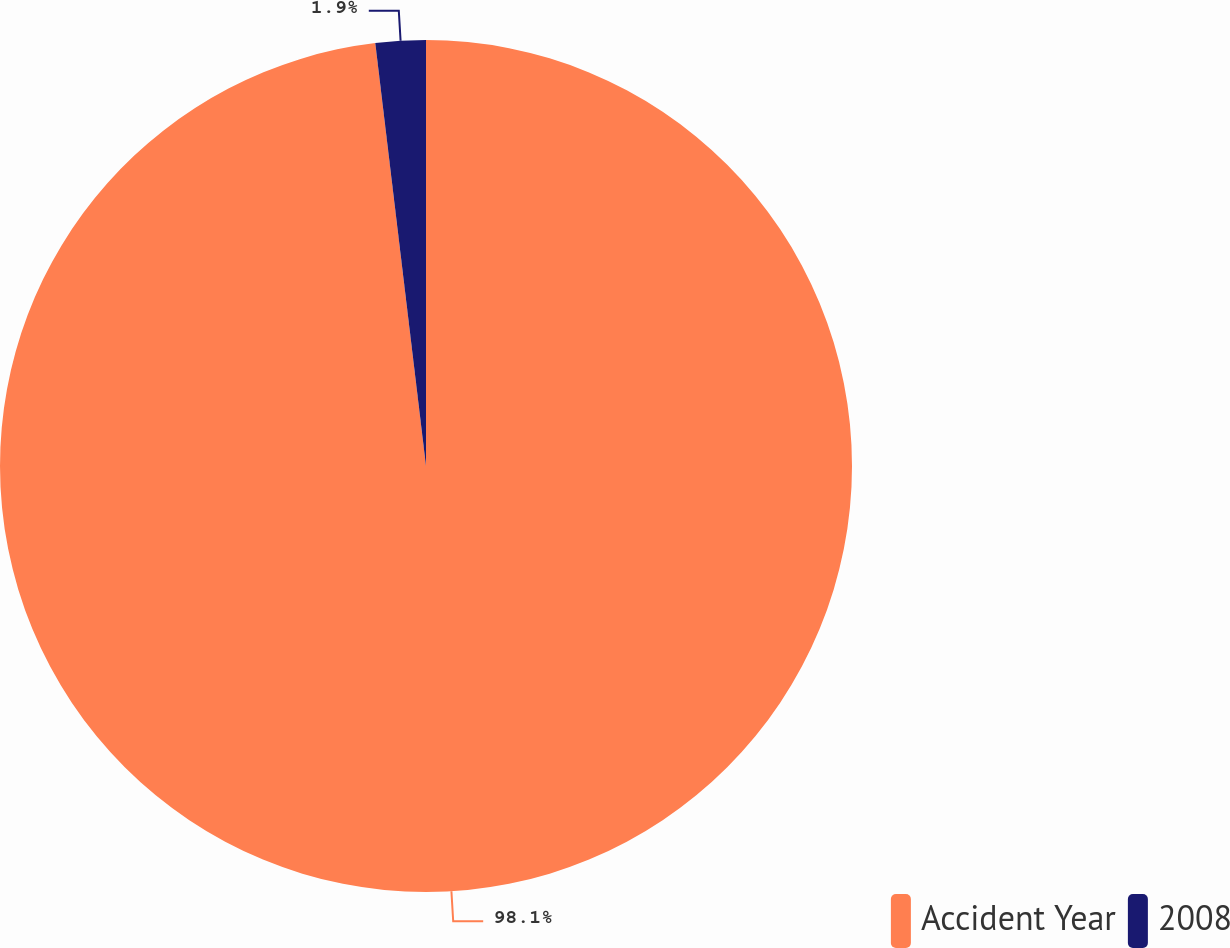Convert chart. <chart><loc_0><loc_0><loc_500><loc_500><pie_chart><fcel>Accident Year<fcel>2008<nl><fcel>98.1%<fcel>1.9%<nl></chart> 